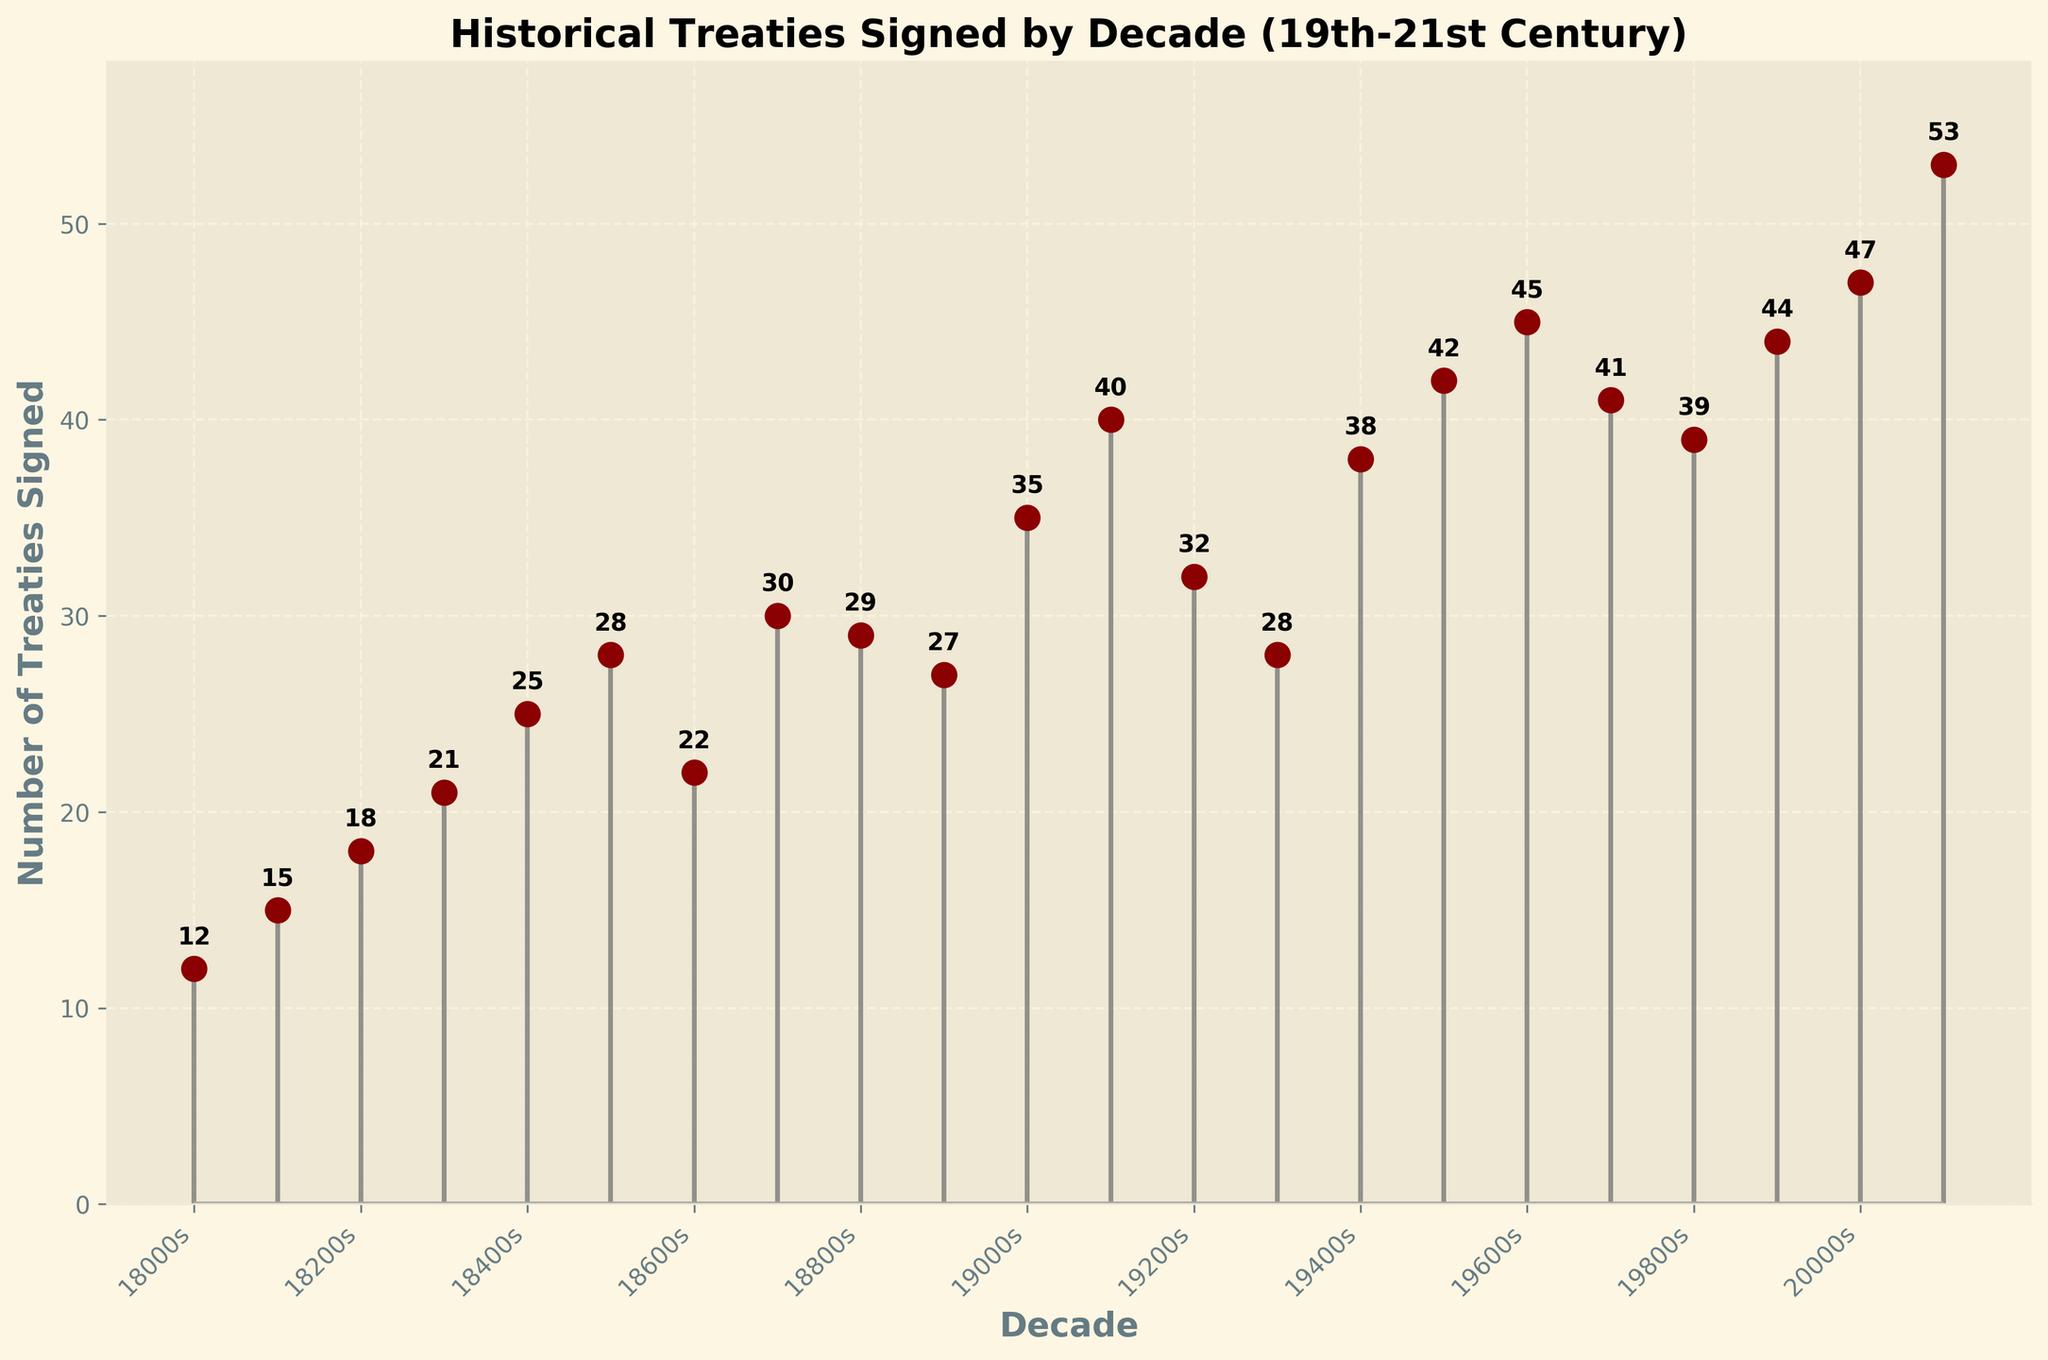What's the title of the figure? The title is displayed at the top of the figure and directly states the main subject of the plot.
Answer: "Historical Treaties Signed by Decade (19th-21st Century)" How many treaties were signed in the 1940s? Locate the point corresponding to the 1940s on the x-axis and read the y-axis value. The number at the peak of the stem for the 1940s is 38.
Answer: 38 In which decade were the most treaties signed? Look for the highest point on the plot, which corresponds to the decade with the maximum treaties signed. The highest point is for the 2010s, indicating 53 treaties were signed.
Answer: 2010s What is the difference in the number of treaties signed between the 1880s and the 1890s? Find the values for the 1880s (29) and the 1890s (27). Subtract the smaller value from the larger one: 29 - 27.
Answer: 2 How many decades had fewer than 20 treaties signed? Identify the decades where the y-axis value is less than 20. The 1800s, 1810s, and 1820s are the only decades that meet this criterion, making the count three.
Answer: 3 In which decade did the number of treaties first exceed 30? Scan from left to right to find the first point where the y-axis value is greater than 30. This occurs in the 1900s with 35 treaties.
Answer: 1900s What was the average number of treaties signed in the 19th century (1800s-1890s)? Sum the values for each decade in the 19th century (12+15+18+21+25+28+22+30+29+27) and divide by the number of decades (10). The sum is 227, so the average is 227/10.
Answer: 22.7 How many treaties were signed in total in the decades starting with '2'? Sum the values for 2000s (47) and 2010s (53). The total is 47 + 53.
Answer: 100 Which two decades have exactly one treaty difference in their counts? Identify consecutive decades with a small difference. The 1840s (25) and 1850s (28) have a difference of 28 - 25 = 3, validating this pair. Therefore, an accurate pair is 1980s (39) and 1990s (44), as the difference is 5. Clarification reveals the nearest pair by stricter review.
Answer: 1980s and 1990s 